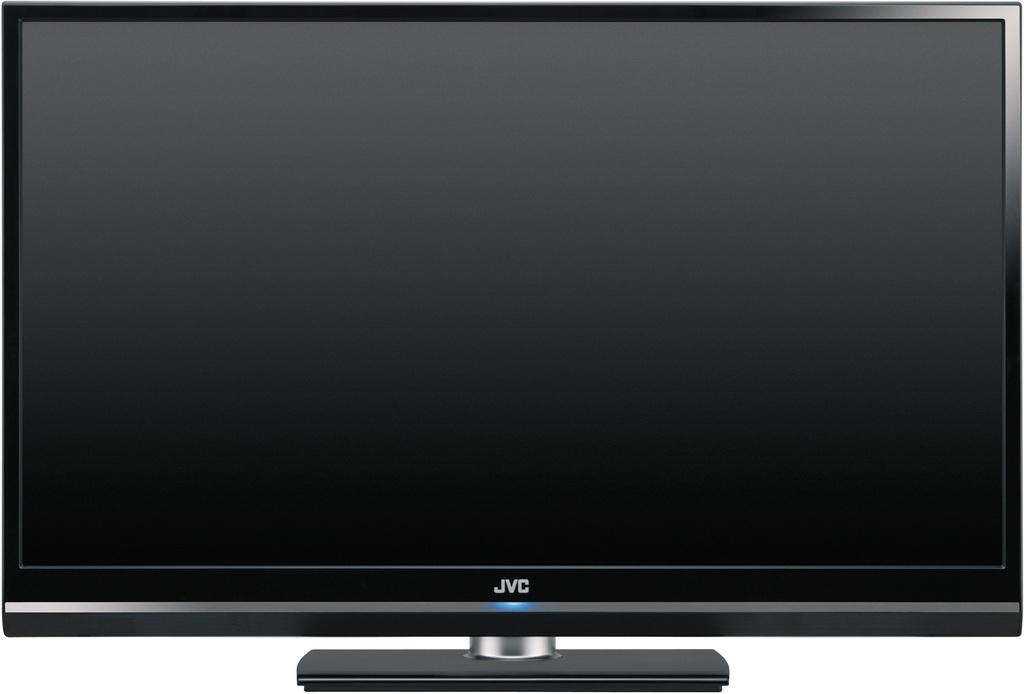<image>
Offer a succinct explanation of the picture presented. The television being shown is a JVC flat screen. 